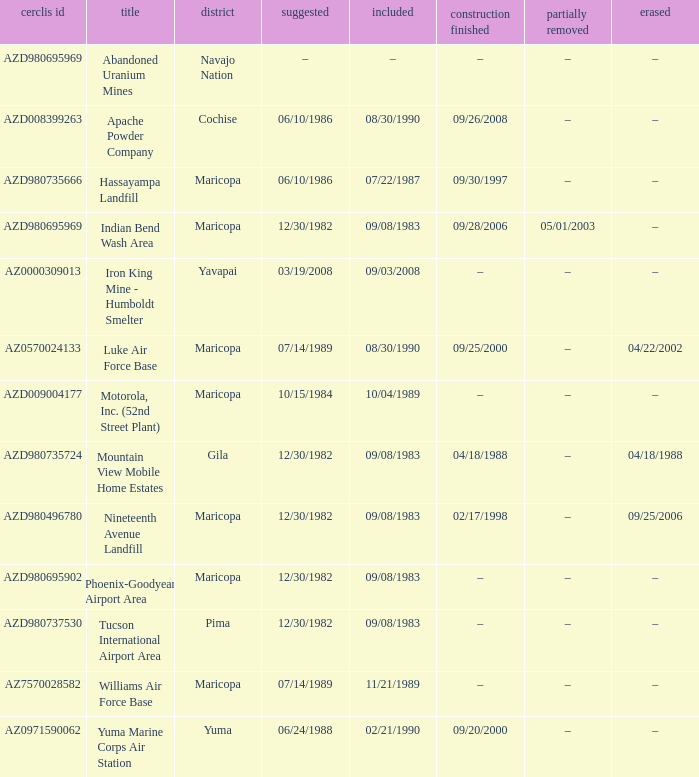When was the site partially deleted when the cerclis id is az7570028582? –. 